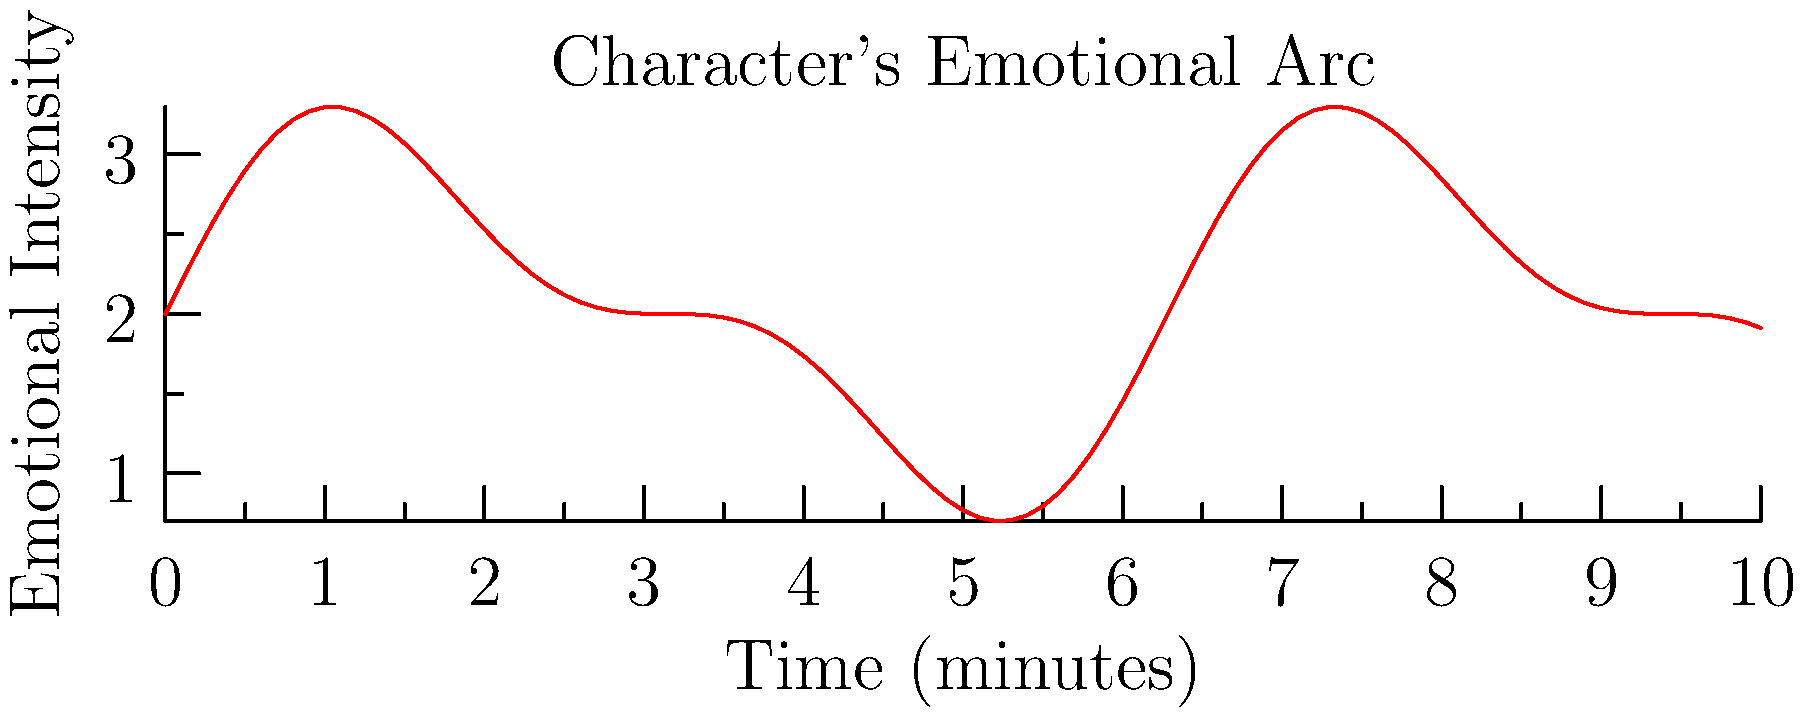In the emotional intensity graph of a character's arc throughout a film, identify the time interval where the character experiences the most rapid increase in emotional intensity. How might you, as a method actor, prepare to portray this sudden surge of emotion? To answer this question, we need to analyze the graph and understand its implications for character development:

1. Observe the graph: The y-axis represents emotional intensity, while the x-axis represents time.

2. Identify the steepest positive slope: This indicates the most rapid increase in emotional intensity. The steepest positive slope appears to be between approximately 4.5 and 5.5 on the x-axis.

3. Interpret the character's emotional state: This rapid increase suggests a sudden, intense emotional change for the character, possibly due to a pivotal moment or revelation in the film.

4. Method acting approach:
   a) Research the context: Understand the events leading up to this moment in the script.
   b) Personal connection: Draw from personal experiences that evoke similar emotions.
   c) Sensory recall: Use sense memory techniques to recreate the physical sensations associated with intense emotions.
   d) Progressive intensification: Practice the scene multiple times, gradually increasing the emotional intensity to match the graph.
   e) Physical preparation: Engage in activities that raise heart rate and adrenaline before the scene to mirror the character's physiological state.
   f) Emotional isolation: If appropriate, isolate yourself before filming to maintain the required emotional state.
   g) Collaboration: Work closely with the director to ensure your interpretation aligns with their vision for the scene.

5. Continuous graph analysis: Note that the emotional intensity fluctuates throughout the film, requiring sustained character development and emotional preparation beyond this single moment.
Answer: Prepare through research, personal connection, sensory recall, progressive intensification, physical preparation, emotional isolation, and collaboration. 